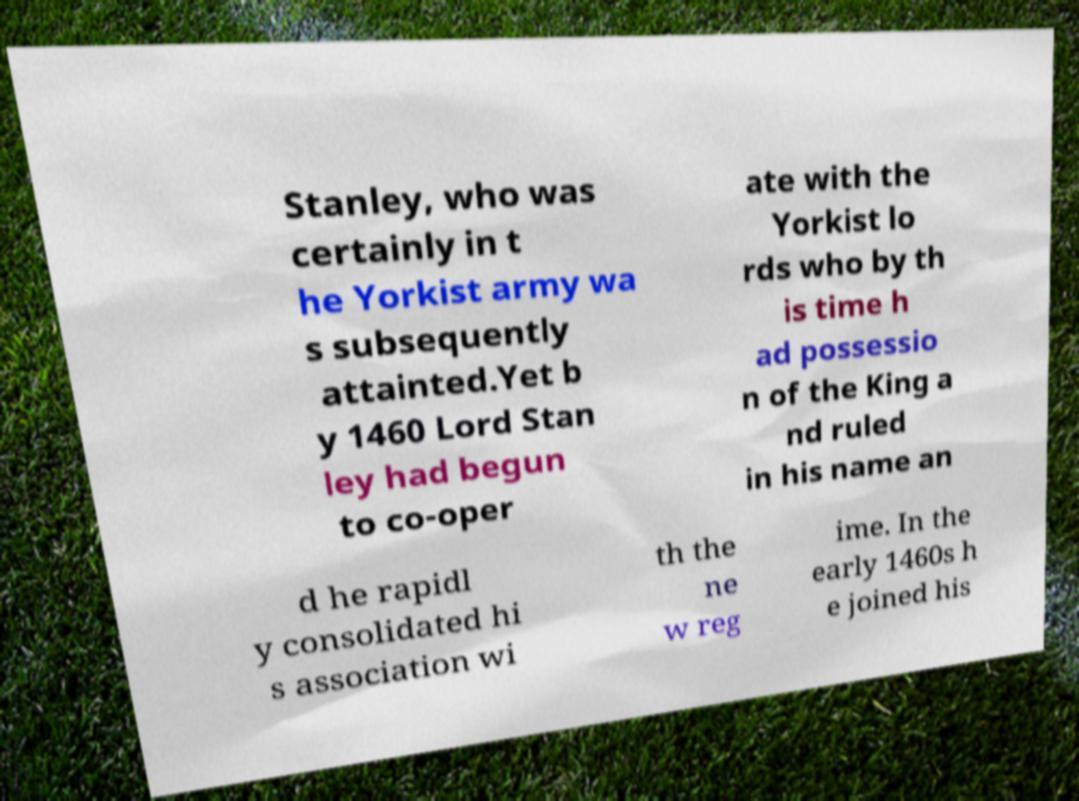Can you read and provide the text displayed in the image?This photo seems to have some interesting text. Can you extract and type it out for me? Stanley, who was certainly in t he Yorkist army wa s subsequently attainted.Yet b y 1460 Lord Stan ley had begun to co-oper ate with the Yorkist lo rds who by th is time h ad possessio n of the King a nd ruled in his name an d he rapidl y consolidated hi s association wi th the ne w reg ime. In the early 1460s h e joined his 